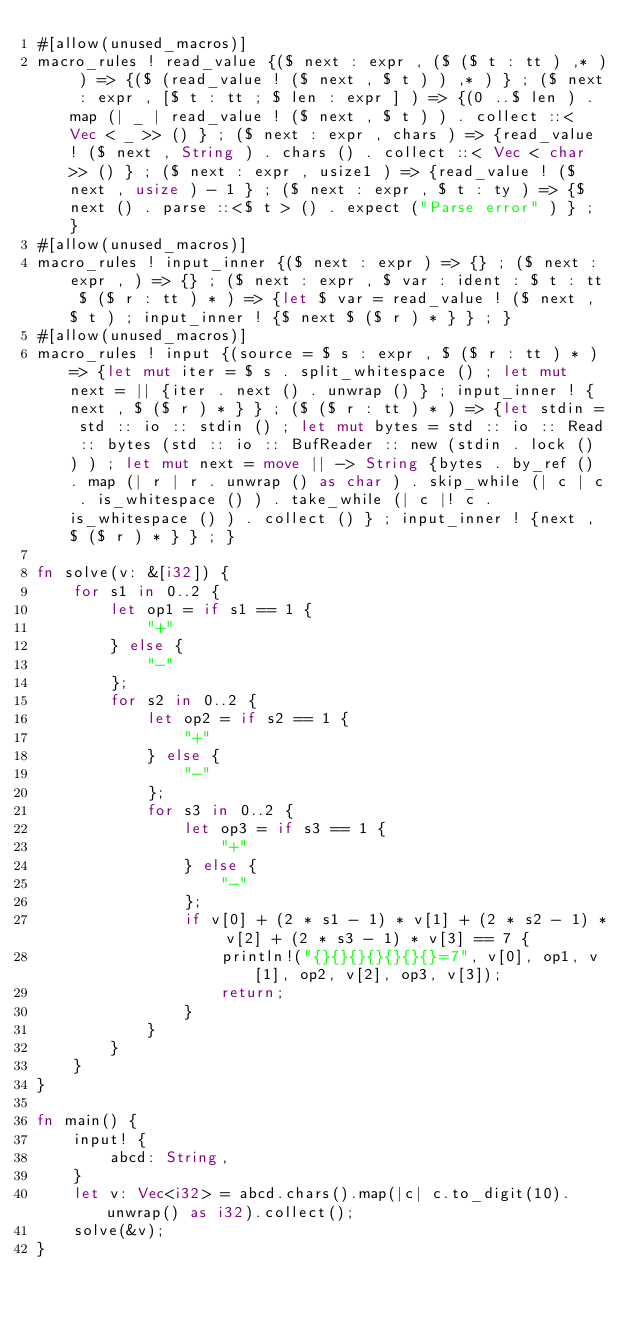Convert code to text. <code><loc_0><loc_0><loc_500><loc_500><_Rust_>#[allow(unused_macros)]
macro_rules ! read_value {($ next : expr , ($ ($ t : tt ) ,* ) ) => {($ (read_value ! ($ next , $ t ) ) ,* ) } ; ($ next : expr , [$ t : tt ; $ len : expr ] ) => {(0 ..$ len ) . map (| _ | read_value ! ($ next , $ t ) ) . collect ::< Vec < _ >> () } ; ($ next : expr , chars ) => {read_value ! ($ next , String ) . chars () . collect ::< Vec < char >> () } ; ($ next : expr , usize1 ) => {read_value ! ($ next , usize ) - 1 } ; ($ next : expr , $ t : ty ) => {$ next () . parse ::<$ t > () . expect ("Parse error" ) } ; }
#[allow(unused_macros)]
macro_rules ! input_inner {($ next : expr ) => {} ; ($ next : expr , ) => {} ; ($ next : expr , $ var : ident : $ t : tt $ ($ r : tt ) * ) => {let $ var = read_value ! ($ next , $ t ) ; input_inner ! {$ next $ ($ r ) * } } ; }
#[allow(unused_macros)]
macro_rules ! input {(source = $ s : expr , $ ($ r : tt ) * ) => {let mut iter = $ s . split_whitespace () ; let mut next = || {iter . next () . unwrap () } ; input_inner ! {next , $ ($ r ) * } } ; ($ ($ r : tt ) * ) => {let stdin = std :: io :: stdin () ; let mut bytes = std :: io :: Read :: bytes (std :: io :: BufReader :: new (stdin . lock () ) ) ; let mut next = move || -> String {bytes . by_ref () . map (| r | r . unwrap () as char ) . skip_while (| c | c . is_whitespace () ) . take_while (| c |! c . is_whitespace () ) . collect () } ; input_inner ! {next , $ ($ r ) * } } ; }

fn solve(v: &[i32]) {
    for s1 in 0..2 {
        let op1 = if s1 == 1 {
            "+"
        } else {
            "-"
        };
        for s2 in 0..2 {
            let op2 = if s2 == 1 {
                "+"
            } else {
                "-"
            };
            for s3 in 0..2 {
                let op3 = if s3 == 1 {
                    "+"
                } else {
                    "-"
                };
                if v[0] + (2 * s1 - 1) * v[1] + (2 * s2 - 1) * v[2] + (2 * s3 - 1) * v[3] == 7 {
                    println!("{}{}{}{}{}{}{}=7", v[0], op1, v[1], op2, v[2], op3, v[3]);
                    return;
                }
            }
        }
    }
}

fn main() {
    input! {
        abcd: String,
    }
    let v: Vec<i32> = abcd.chars().map(|c| c.to_digit(10).unwrap() as i32).collect();
    solve(&v);
}
</code> 